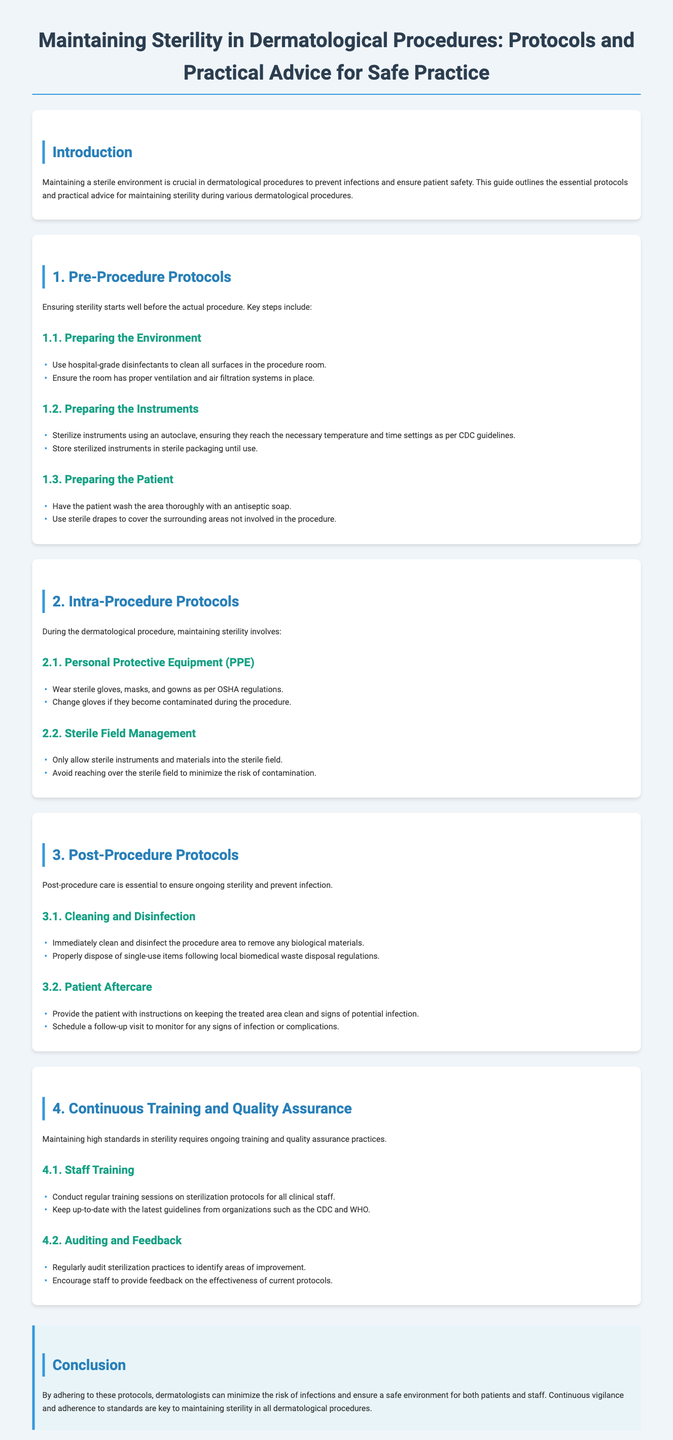What is the purpose of maintaining a sterile environment? The purpose is to prevent infections and ensure patient safety during dermatological procedures.
Answer: Prevent infections and ensure patient safety What disinfectants should be used in the procedure room? The document specifies using hospital-grade disinfectants to clean surfaces in the procedure room.
Answer: Hospital-grade disinfectants What should be done to the instruments before a procedure? Instruments should be sterilized using an autoclave, according to CDC guidelines.
Answer: Sterilized using an autoclave What must a patient do before a dermatological procedure? The patient must wash the area thoroughly with an antiseptic soap.
Answer: Wash with antiseptic soap What is recommended if gloves become contaminated? The document recommends changing gloves if they become contaminated during the procedure.
Answer: Change gloves What is essential for post-procedure care? Providing instructions to the patient on keeping the treated area clean is essential.
Answer: Instructions on keeping the treated area clean What type of sessions should be conducted regularly for staff? Regular training sessions on sterilization protocols should be conducted for all clinical staff.
Answer: Training sessions on sterilization protocols What is the goal of auditing sterilization practices? The goal is to identify areas of improvement in sterilization practices.
Answer: Identify areas of improvement What attitude should be encouraged regarding current protocols? Staff should be encouraged to provide feedback on the effectiveness of current protocols.
Answer: Provide feedback on current protocols 